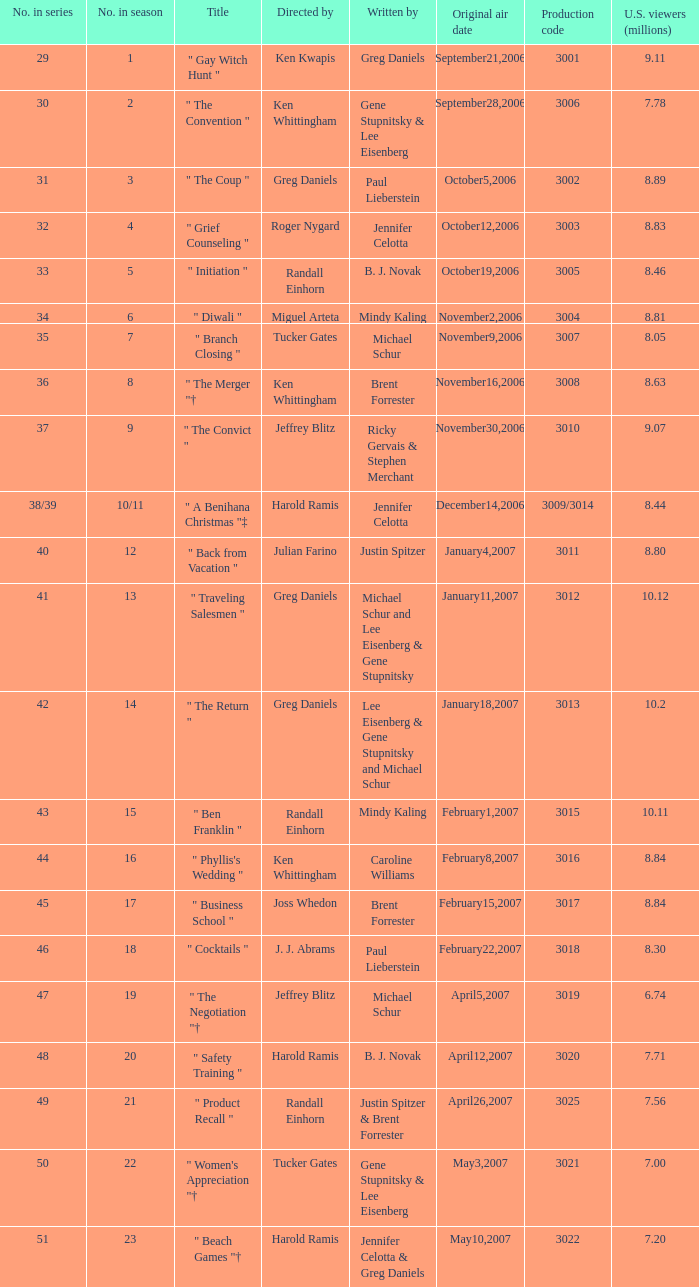Name the total number of titles for 3020 production code 1.0. 